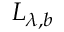<formula> <loc_0><loc_0><loc_500><loc_500>L _ { \lambda , b }</formula> 